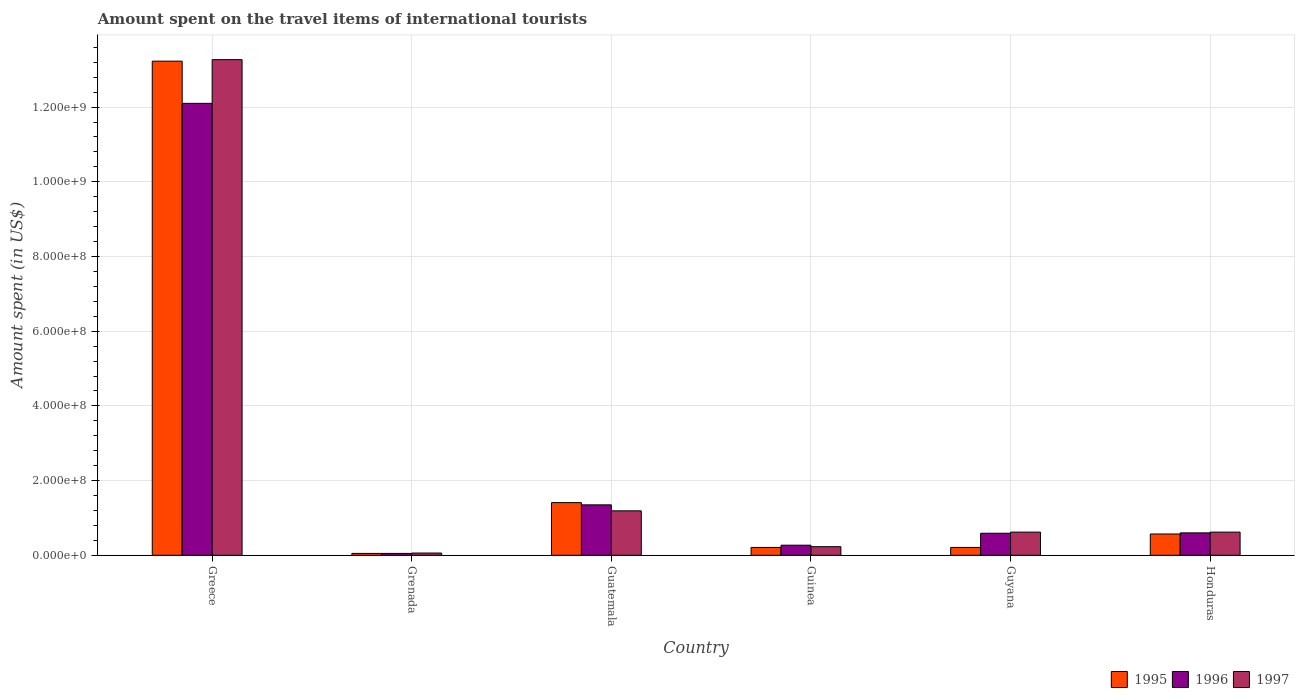Are the number of bars per tick equal to the number of legend labels?
Make the answer very short. Yes. How many bars are there on the 3rd tick from the right?
Your answer should be compact. 3. What is the label of the 4th group of bars from the left?
Provide a short and direct response. Guinea. In how many cases, is the number of bars for a given country not equal to the number of legend labels?
Your answer should be very brief. 0. What is the amount spent on the travel items of international tourists in 1997 in Greece?
Offer a terse response. 1.33e+09. Across all countries, what is the maximum amount spent on the travel items of international tourists in 1996?
Make the answer very short. 1.21e+09. In which country was the amount spent on the travel items of international tourists in 1995 minimum?
Your response must be concise. Grenada. What is the total amount spent on the travel items of international tourists in 1997 in the graph?
Make the answer very short. 1.60e+09. What is the difference between the amount spent on the travel items of international tourists in 1995 in Grenada and that in Honduras?
Provide a short and direct response. -5.20e+07. What is the difference between the amount spent on the travel items of international tourists in 1995 in Guatemala and the amount spent on the travel items of international tourists in 1996 in Guinea?
Keep it short and to the point. 1.14e+08. What is the average amount spent on the travel items of international tourists in 1997 per country?
Ensure brevity in your answer.  2.66e+08. What is the difference between the amount spent on the travel items of international tourists of/in 1996 and amount spent on the travel items of international tourists of/in 1997 in Honduras?
Offer a very short reply. -2.00e+06. In how many countries, is the amount spent on the travel items of international tourists in 1995 greater than 600000000 US$?
Give a very brief answer. 1. What is the ratio of the amount spent on the travel items of international tourists in 1996 in Grenada to that in Honduras?
Your answer should be compact. 0.08. Is the difference between the amount spent on the travel items of international tourists in 1996 in Greece and Guinea greater than the difference between the amount spent on the travel items of international tourists in 1997 in Greece and Guinea?
Your response must be concise. No. What is the difference between the highest and the second highest amount spent on the travel items of international tourists in 1996?
Offer a terse response. 1.15e+09. What is the difference between the highest and the lowest amount spent on the travel items of international tourists in 1996?
Ensure brevity in your answer.  1.20e+09. In how many countries, is the amount spent on the travel items of international tourists in 1995 greater than the average amount spent on the travel items of international tourists in 1995 taken over all countries?
Offer a very short reply. 1. What does the 1st bar from the left in Grenada represents?
Your response must be concise. 1995. Is it the case that in every country, the sum of the amount spent on the travel items of international tourists in 1996 and amount spent on the travel items of international tourists in 1995 is greater than the amount spent on the travel items of international tourists in 1997?
Make the answer very short. Yes. How many bars are there?
Your answer should be very brief. 18. Are all the bars in the graph horizontal?
Ensure brevity in your answer.  No. What is the difference between two consecutive major ticks on the Y-axis?
Keep it short and to the point. 2.00e+08. Where does the legend appear in the graph?
Keep it short and to the point. Bottom right. What is the title of the graph?
Offer a terse response. Amount spent on the travel items of international tourists. Does "1998" appear as one of the legend labels in the graph?
Make the answer very short. No. What is the label or title of the Y-axis?
Offer a very short reply. Amount spent (in US$). What is the Amount spent (in US$) of 1995 in Greece?
Make the answer very short. 1.32e+09. What is the Amount spent (in US$) of 1996 in Greece?
Provide a short and direct response. 1.21e+09. What is the Amount spent (in US$) of 1997 in Greece?
Provide a short and direct response. 1.33e+09. What is the Amount spent (in US$) in 1996 in Grenada?
Provide a short and direct response. 5.00e+06. What is the Amount spent (in US$) in 1995 in Guatemala?
Offer a very short reply. 1.41e+08. What is the Amount spent (in US$) of 1996 in Guatemala?
Make the answer very short. 1.35e+08. What is the Amount spent (in US$) in 1997 in Guatemala?
Your answer should be compact. 1.19e+08. What is the Amount spent (in US$) in 1995 in Guinea?
Your answer should be compact. 2.10e+07. What is the Amount spent (in US$) in 1996 in Guinea?
Your answer should be very brief. 2.70e+07. What is the Amount spent (in US$) of 1997 in Guinea?
Your answer should be very brief. 2.30e+07. What is the Amount spent (in US$) of 1995 in Guyana?
Your response must be concise. 2.10e+07. What is the Amount spent (in US$) in 1996 in Guyana?
Make the answer very short. 5.90e+07. What is the Amount spent (in US$) of 1997 in Guyana?
Make the answer very short. 6.20e+07. What is the Amount spent (in US$) of 1995 in Honduras?
Give a very brief answer. 5.70e+07. What is the Amount spent (in US$) in 1996 in Honduras?
Provide a short and direct response. 6.00e+07. What is the Amount spent (in US$) in 1997 in Honduras?
Offer a terse response. 6.20e+07. Across all countries, what is the maximum Amount spent (in US$) of 1995?
Keep it short and to the point. 1.32e+09. Across all countries, what is the maximum Amount spent (in US$) in 1996?
Your response must be concise. 1.21e+09. Across all countries, what is the maximum Amount spent (in US$) in 1997?
Make the answer very short. 1.33e+09. Across all countries, what is the minimum Amount spent (in US$) of 1995?
Your answer should be very brief. 5.00e+06. Across all countries, what is the minimum Amount spent (in US$) in 1996?
Your answer should be compact. 5.00e+06. Across all countries, what is the minimum Amount spent (in US$) of 1997?
Offer a very short reply. 6.00e+06. What is the total Amount spent (in US$) in 1995 in the graph?
Make the answer very short. 1.57e+09. What is the total Amount spent (in US$) of 1996 in the graph?
Give a very brief answer. 1.50e+09. What is the total Amount spent (in US$) in 1997 in the graph?
Ensure brevity in your answer.  1.60e+09. What is the difference between the Amount spent (in US$) of 1995 in Greece and that in Grenada?
Provide a succinct answer. 1.32e+09. What is the difference between the Amount spent (in US$) in 1996 in Greece and that in Grenada?
Offer a very short reply. 1.20e+09. What is the difference between the Amount spent (in US$) of 1997 in Greece and that in Grenada?
Ensure brevity in your answer.  1.32e+09. What is the difference between the Amount spent (in US$) in 1995 in Greece and that in Guatemala?
Offer a terse response. 1.18e+09. What is the difference between the Amount spent (in US$) of 1996 in Greece and that in Guatemala?
Provide a succinct answer. 1.08e+09. What is the difference between the Amount spent (in US$) in 1997 in Greece and that in Guatemala?
Ensure brevity in your answer.  1.21e+09. What is the difference between the Amount spent (in US$) in 1995 in Greece and that in Guinea?
Keep it short and to the point. 1.30e+09. What is the difference between the Amount spent (in US$) in 1996 in Greece and that in Guinea?
Keep it short and to the point. 1.18e+09. What is the difference between the Amount spent (in US$) of 1997 in Greece and that in Guinea?
Offer a very short reply. 1.30e+09. What is the difference between the Amount spent (in US$) in 1995 in Greece and that in Guyana?
Offer a terse response. 1.30e+09. What is the difference between the Amount spent (in US$) in 1996 in Greece and that in Guyana?
Make the answer very short. 1.15e+09. What is the difference between the Amount spent (in US$) of 1997 in Greece and that in Guyana?
Provide a succinct answer. 1.26e+09. What is the difference between the Amount spent (in US$) in 1995 in Greece and that in Honduras?
Ensure brevity in your answer.  1.27e+09. What is the difference between the Amount spent (in US$) in 1996 in Greece and that in Honduras?
Your answer should be very brief. 1.15e+09. What is the difference between the Amount spent (in US$) of 1997 in Greece and that in Honduras?
Your answer should be compact. 1.26e+09. What is the difference between the Amount spent (in US$) of 1995 in Grenada and that in Guatemala?
Offer a very short reply. -1.36e+08. What is the difference between the Amount spent (in US$) of 1996 in Grenada and that in Guatemala?
Ensure brevity in your answer.  -1.30e+08. What is the difference between the Amount spent (in US$) in 1997 in Grenada and that in Guatemala?
Offer a very short reply. -1.13e+08. What is the difference between the Amount spent (in US$) of 1995 in Grenada and that in Guinea?
Ensure brevity in your answer.  -1.60e+07. What is the difference between the Amount spent (in US$) of 1996 in Grenada and that in Guinea?
Provide a succinct answer. -2.20e+07. What is the difference between the Amount spent (in US$) in 1997 in Grenada and that in Guinea?
Offer a terse response. -1.70e+07. What is the difference between the Amount spent (in US$) in 1995 in Grenada and that in Guyana?
Provide a short and direct response. -1.60e+07. What is the difference between the Amount spent (in US$) in 1996 in Grenada and that in Guyana?
Your answer should be very brief. -5.40e+07. What is the difference between the Amount spent (in US$) of 1997 in Grenada and that in Guyana?
Offer a terse response. -5.60e+07. What is the difference between the Amount spent (in US$) in 1995 in Grenada and that in Honduras?
Provide a succinct answer. -5.20e+07. What is the difference between the Amount spent (in US$) in 1996 in Grenada and that in Honduras?
Make the answer very short. -5.50e+07. What is the difference between the Amount spent (in US$) in 1997 in Grenada and that in Honduras?
Make the answer very short. -5.60e+07. What is the difference between the Amount spent (in US$) in 1995 in Guatemala and that in Guinea?
Ensure brevity in your answer.  1.20e+08. What is the difference between the Amount spent (in US$) of 1996 in Guatemala and that in Guinea?
Your response must be concise. 1.08e+08. What is the difference between the Amount spent (in US$) of 1997 in Guatemala and that in Guinea?
Provide a succinct answer. 9.60e+07. What is the difference between the Amount spent (in US$) of 1995 in Guatemala and that in Guyana?
Offer a very short reply. 1.20e+08. What is the difference between the Amount spent (in US$) of 1996 in Guatemala and that in Guyana?
Your answer should be compact. 7.60e+07. What is the difference between the Amount spent (in US$) of 1997 in Guatemala and that in Guyana?
Your response must be concise. 5.70e+07. What is the difference between the Amount spent (in US$) of 1995 in Guatemala and that in Honduras?
Provide a succinct answer. 8.40e+07. What is the difference between the Amount spent (in US$) of 1996 in Guatemala and that in Honduras?
Your response must be concise. 7.50e+07. What is the difference between the Amount spent (in US$) in 1997 in Guatemala and that in Honduras?
Provide a succinct answer. 5.70e+07. What is the difference between the Amount spent (in US$) in 1995 in Guinea and that in Guyana?
Your answer should be very brief. 0. What is the difference between the Amount spent (in US$) in 1996 in Guinea and that in Guyana?
Offer a very short reply. -3.20e+07. What is the difference between the Amount spent (in US$) of 1997 in Guinea and that in Guyana?
Your answer should be very brief. -3.90e+07. What is the difference between the Amount spent (in US$) of 1995 in Guinea and that in Honduras?
Make the answer very short. -3.60e+07. What is the difference between the Amount spent (in US$) in 1996 in Guinea and that in Honduras?
Provide a short and direct response. -3.30e+07. What is the difference between the Amount spent (in US$) in 1997 in Guinea and that in Honduras?
Keep it short and to the point. -3.90e+07. What is the difference between the Amount spent (in US$) of 1995 in Guyana and that in Honduras?
Give a very brief answer. -3.60e+07. What is the difference between the Amount spent (in US$) of 1997 in Guyana and that in Honduras?
Your response must be concise. 0. What is the difference between the Amount spent (in US$) of 1995 in Greece and the Amount spent (in US$) of 1996 in Grenada?
Give a very brief answer. 1.32e+09. What is the difference between the Amount spent (in US$) in 1995 in Greece and the Amount spent (in US$) in 1997 in Grenada?
Your response must be concise. 1.32e+09. What is the difference between the Amount spent (in US$) in 1996 in Greece and the Amount spent (in US$) in 1997 in Grenada?
Your answer should be very brief. 1.20e+09. What is the difference between the Amount spent (in US$) in 1995 in Greece and the Amount spent (in US$) in 1996 in Guatemala?
Give a very brief answer. 1.19e+09. What is the difference between the Amount spent (in US$) of 1995 in Greece and the Amount spent (in US$) of 1997 in Guatemala?
Make the answer very short. 1.20e+09. What is the difference between the Amount spent (in US$) of 1996 in Greece and the Amount spent (in US$) of 1997 in Guatemala?
Make the answer very short. 1.09e+09. What is the difference between the Amount spent (in US$) of 1995 in Greece and the Amount spent (in US$) of 1996 in Guinea?
Your answer should be very brief. 1.30e+09. What is the difference between the Amount spent (in US$) of 1995 in Greece and the Amount spent (in US$) of 1997 in Guinea?
Your response must be concise. 1.30e+09. What is the difference between the Amount spent (in US$) of 1996 in Greece and the Amount spent (in US$) of 1997 in Guinea?
Your response must be concise. 1.19e+09. What is the difference between the Amount spent (in US$) of 1995 in Greece and the Amount spent (in US$) of 1996 in Guyana?
Keep it short and to the point. 1.26e+09. What is the difference between the Amount spent (in US$) of 1995 in Greece and the Amount spent (in US$) of 1997 in Guyana?
Your answer should be very brief. 1.26e+09. What is the difference between the Amount spent (in US$) in 1996 in Greece and the Amount spent (in US$) in 1997 in Guyana?
Offer a very short reply. 1.15e+09. What is the difference between the Amount spent (in US$) of 1995 in Greece and the Amount spent (in US$) of 1996 in Honduras?
Keep it short and to the point. 1.26e+09. What is the difference between the Amount spent (in US$) of 1995 in Greece and the Amount spent (in US$) of 1997 in Honduras?
Make the answer very short. 1.26e+09. What is the difference between the Amount spent (in US$) in 1996 in Greece and the Amount spent (in US$) in 1997 in Honduras?
Keep it short and to the point. 1.15e+09. What is the difference between the Amount spent (in US$) in 1995 in Grenada and the Amount spent (in US$) in 1996 in Guatemala?
Give a very brief answer. -1.30e+08. What is the difference between the Amount spent (in US$) in 1995 in Grenada and the Amount spent (in US$) in 1997 in Guatemala?
Offer a very short reply. -1.14e+08. What is the difference between the Amount spent (in US$) of 1996 in Grenada and the Amount spent (in US$) of 1997 in Guatemala?
Your answer should be compact. -1.14e+08. What is the difference between the Amount spent (in US$) in 1995 in Grenada and the Amount spent (in US$) in 1996 in Guinea?
Give a very brief answer. -2.20e+07. What is the difference between the Amount spent (in US$) of 1995 in Grenada and the Amount spent (in US$) of 1997 in Guinea?
Provide a short and direct response. -1.80e+07. What is the difference between the Amount spent (in US$) in 1996 in Grenada and the Amount spent (in US$) in 1997 in Guinea?
Provide a short and direct response. -1.80e+07. What is the difference between the Amount spent (in US$) in 1995 in Grenada and the Amount spent (in US$) in 1996 in Guyana?
Your response must be concise. -5.40e+07. What is the difference between the Amount spent (in US$) of 1995 in Grenada and the Amount spent (in US$) of 1997 in Guyana?
Provide a short and direct response. -5.70e+07. What is the difference between the Amount spent (in US$) in 1996 in Grenada and the Amount spent (in US$) in 1997 in Guyana?
Keep it short and to the point. -5.70e+07. What is the difference between the Amount spent (in US$) of 1995 in Grenada and the Amount spent (in US$) of 1996 in Honduras?
Make the answer very short. -5.50e+07. What is the difference between the Amount spent (in US$) of 1995 in Grenada and the Amount spent (in US$) of 1997 in Honduras?
Your answer should be very brief. -5.70e+07. What is the difference between the Amount spent (in US$) of 1996 in Grenada and the Amount spent (in US$) of 1997 in Honduras?
Your response must be concise. -5.70e+07. What is the difference between the Amount spent (in US$) in 1995 in Guatemala and the Amount spent (in US$) in 1996 in Guinea?
Ensure brevity in your answer.  1.14e+08. What is the difference between the Amount spent (in US$) in 1995 in Guatemala and the Amount spent (in US$) in 1997 in Guinea?
Provide a succinct answer. 1.18e+08. What is the difference between the Amount spent (in US$) of 1996 in Guatemala and the Amount spent (in US$) of 1997 in Guinea?
Keep it short and to the point. 1.12e+08. What is the difference between the Amount spent (in US$) in 1995 in Guatemala and the Amount spent (in US$) in 1996 in Guyana?
Provide a succinct answer. 8.20e+07. What is the difference between the Amount spent (in US$) in 1995 in Guatemala and the Amount spent (in US$) in 1997 in Guyana?
Your response must be concise. 7.90e+07. What is the difference between the Amount spent (in US$) in 1996 in Guatemala and the Amount spent (in US$) in 1997 in Guyana?
Your answer should be compact. 7.30e+07. What is the difference between the Amount spent (in US$) in 1995 in Guatemala and the Amount spent (in US$) in 1996 in Honduras?
Your response must be concise. 8.10e+07. What is the difference between the Amount spent (in US$) in 1995 in Guatemala and the Amount spent (in US$) in 1997 in Honduras?
Offer a very short reply. 7.90e+07. What is the difference between the Amount spent (in US$) of 1996 in Guatemala and the Amount spent (in US$) of 1997 in Honduras?
Ensure brevity in your answer.  7.30e+07. What is the difference between the Amount spent (in US$) in 1995 in Guinea and the Amount spent (in US$) in 1996 in Guyana?
Make the answer very short. -3.80e+07. What is the difference between the Amount spent (in US$) in 1995 in Guinea and the Amount spent (in US$) in 1997 in Guyana?
Give a very brief answer. -4.10e+07. What is the difference between the Amount spent (in US$) in 1996 in Guinea and the Amount spent (in US$) in 1997 in Guyana?
Provide a succinct answer. -3.50e+07. What is the difference between the Amount spent (in US$) in 1995 in Guinea and the Amount spent (in US$) in 1996 in Honduras?
Your answer should be compact. -3.90e+07. What is the difference between the Amount spent (in US$) of 1995 in Guinea and the Amount spent (in US$) of 1997 in Honduras?
Keep it short and to the point. -4.10e+07. What is the difference between the Amount spent (in US$) of 1996 in Guinea and the Amount spent (in US$) of 1997 in Honduras?
Provide a short and direct response. -3.50e+07. What is the difference between the Amount spent (in US$) in 1995 in Guyana and the Amount spent (in US$) in 1996 in Honduras?
Your response must be concise. -3.90e+07. What is the difference between the Amount spent (in US$) in 1995 in Guyana and the Amount spent (in US$) in 1997 in Honduras?
Offer a very short reply. -4.10e+07. What is the average Amount spent (in US$) in 1995 per country?
Your answer should be compact. 2.61e+08. What is the average Amount spent (in US$) of 1996 per country?
Your answer should be very brief. 2.49e+08. What is the average Amount spent (in US$) in 1997 per country?
Offer a terse response. 2.66e+08. What is the difference between the Amount spent (in US$) of 1995 and Amount spent (in US$) of 1996 in Greece?
Your answer should be compact. 1.13e+08. What is the difference between the Amount spent (in US$) in 1996 and Amount spent (in US$) in 1997 in Greece?
Keep it short and to the point. -1.17e+08. What is the difference between the Amount spent (in US$) in 1995 and Amount spent (in US$) in 1997 in Guatemala?
Your answer should be compact. 2.20e+07. What is the difference between the Amount spent (in US$) in 1996 and Amount spent (in US$) in 1997 in Guatemala?
Make the answer very short. 1.60e+07. What is the difference between the Amount spent (in US$) in 1995 and Amount spent (in US$) in 1996 in Guinea?
Your response must be concise. -6.00e+06. What is the difference between the Amount spent (in US$) in 1996 and Amount spent (in US$) in 1997 in Guinea?
Offer a very short reply. 4.00e+06. What is the difference between the Amount spent (in US$) of 1995 and Amount spent (in US$) of 1996 in Guyana?
Make the answer very short. -3.80e+07. What is the difference between the Amount spent (in US$) of 1995 and Amount spent (in US$) of 1997 in Guyana?
Ensure brevity in your answer.  -4.10e+07. What is the difference between the Amount spent (in US$) in 1995 and Amount spent (in US$) in 1996 in Honduras?
Keep it short and to the point. -3.00e+06. What is the difference between the Amount spent (in US$) of 1995 and Amount spent (in US$) of 1997 in Honduras?
Offer a very short reply. -5.00e+06. What is the difference between the Amount spent (in US$) of 1996 and Amount spent (in US$) of 1997 in Honduras?
Make the answer very short. -2.00e+06. What is the ratio of the Amount spent (in US$) in 1995 in Greece to that in Grenada?
Make the answer very short. 264.6. What is the ratio of the Amount spent (in US$) of 1996 in Greece to that in Grenada?
Provide a succinct answer. 242. What is the ratio of the Amount spent (in US$) in 1997 in Greece to that in Grenada?
Ensure brevity in your answer.  221.17. What is the ratio of the Amount spent (in US$) of 1995 in Greece to that in Guatemala?
Keep it short and to the point. 9.38. What is the ratio of the Amount spent (in US$) in 1996 in Greece to that in Guatemala?
Offer a terse response. 8.96. What is the ratio of the Amount spent (in US$) in 1997 in Greece to that in Guatemala?
Your answer should be very brief. 11.15. What is the ratio of the Amount spent (in US$) of 1996 in Greece to that in Guinea?
Offer a terse response. 44.81. What is the ratio of the Amount spent (in US$) of 1997 in Greece to that in Guinea?
Offer a terse response. 57.7. What is the ratio of the Amount spent (in US$) of 1995 in Greece to that in Guyana?
Your answer should be very brief. 63. What is the ratio of the Amount spent (in US$) of 1996 in Greece to that in Guyana?
Give a very brief answer. 20.51. What is the ratio of the Amount spent (in US$) in 1997 in Greece to that in Guyana?
Make the answer very short. 21.4. What is the ratio of the Amount spent (in US$) in 1995 in Greece to that in Honduras?
Your answer should be compact. 23.21. What is the ratio of the Amount spent (in US$) of 1996 in Greece to that in Honduras?
Ensure brevity in your answer.  20.17. What is the ratio of the Amount spent (in US$) of 1997 in Greece to that in Honduras?
Your response must be concise. 21.4. What is the ratio of the Amount spent (in US$) in 1995 in Grenada to that in Guatemala?
Make the answer very short. 0.04. What is the ratio of the Amount spent (in US$) of 1996 in Grenada to that in Guatemala?
Make the answer very short. 0.04. What is the ratio of the Amount spent (in US$) of 1997 in Grenada to that in Guatemala?
Keep it short and to the point. 0.05. What is the ratio of the Amount spent (in US$) of 1995 in Grenada to that in Guinea?
Offer a very short reply. 0.24. What is the ratio of the Amount spent (in US$) in 1996 in Grenada to that in Guinea?
Give a very brief answer. 0.19. What is the ratio of the Amount spent (in US$) in 1997 in Grenada to that in Guinea?
Provide a short and direct response. 0.26. What is the ratio of the Amount spent (in US$) of 1995 in Grenada to that in Guyana?
Offer a terse response. 0.24. What is the ratio of the Amount spent (in US$) of 1996 in Grenada to that in Guyana?
Give a very brief answer. 0.08. What is the ratio of the Amount spent (in US$) of 1997 in Grenada to that in Guyana?
Offer a very short reply. 0.1. What is the ratio of the Amount spent (in US$) of 1995 in Grenada to that in Honduras?
Provide a succinct answer. 0.09. What is the ratio of the Amount spent (in US$) of 1996 in Grenada to that in Honduras?
Offer a very short reply. 0.08. What is the ratio of the Amount spent (in US$) of 1997 in Grenada to that in Honduras?
Give a very brief answer. 0.1. What is the ratio of the Amount spent (in US$) of 1995 in Guatemala to that in Guinea?
Offer a very short reply. 6.71. What is the ratio of the Amount spent (in US$) in 1997 in Guatemala to that in Guinea?
Your response must be concise. 5.17. What is the ratio of the Amount spent (in US$) in 1995 in Guatemala to that in Guyana?
Your answer should be very brief. 6.71. What is the ratio of the Amount spent (in US$) of 1996 in Guatemala to that in Guyana?
Offer a very short reply. 2.29. What is the ratio of the Amount spent (in US$) in 1997 in Guatemala to that in Guyana?
Offer a very short reply. 1.92. What is the ratio of the Amount spent (in US$) in 1995 in Guatemala to that in Honduras?
Ensure brevity in your answer.  2.47. What is the ratio of the Amount spent (in US$) of 1996 in Guatemala to that in Honduras?
Offer a very short reply. 2.25. What is the ratio of the Amount spent (in US$) of 1997 in Guatemala to that in Honduras?
Offer a terse response. 1.92. What is the ratio of the Amount spent (in US$) of 1995 in Guinea to that in Guyana?
Offer a terse response. 1. What is the ratio of the Amount spent (in US$) of 1996 in Guinea to that in Guyana?
Your answer should be compact. 0.46. What is the ratio of the Amount spent (in US$) in 1997 in Guinea to that in Guyana?
Your answer should be compact. 0.37. What is the ratio of the Amount spent (in US$) in 1995 in Guinea to that in Honduras?
Your answer should be very brief. 0.37. What is the ratio of the Amount spent (in US$) in 1996 in Guinea to that in Honduras?
Ensure brevity in your answer.  0.45. What is the ratio of the Amount spent (in US$) in 1997 in Guinea to that in Honduras?
Offer a terse response. 0.37. What is the ratio of the Amount spent (in US$) of 1995 in Guyana to that in Honduras?
Your answer should be compact. 0.37. What is the ratio of the Amount spent (in US$) of 1996 in Guyana to that in Honduras?
Offer a terse response. 0.98. What is the ratio of the Amount spent (in US$) of 1997 in Guyana to that in Honduras?
Make the answer very short. 1. What is the difference between the highest and the second highest Amount spent (in US$) of 1995?
Offer a very short reply. 1.18e+09. What is the difference between the highest and the second highest Amount spent (in US$) in 1996?
Provide a succinct answer. 1.08e+09. What is the difference between the highest and the second highest Amount spent (in US$) of 1997?
Provide a succinct answer. 1.21e+09. What is the difference between the highest and the lowest Amount spent (in US$) of 1995?
Provide a short and direct response. 1.32e+09. What is the difference between the highest and the lowest Amount spent (in US$) in 1996?
Provide a succinct answer. 1.20e+09. What is the difference between the highest and the lowest Amount spent (in US$) of 1997?
Ensure brevity in your answer.  1.32e+09. 